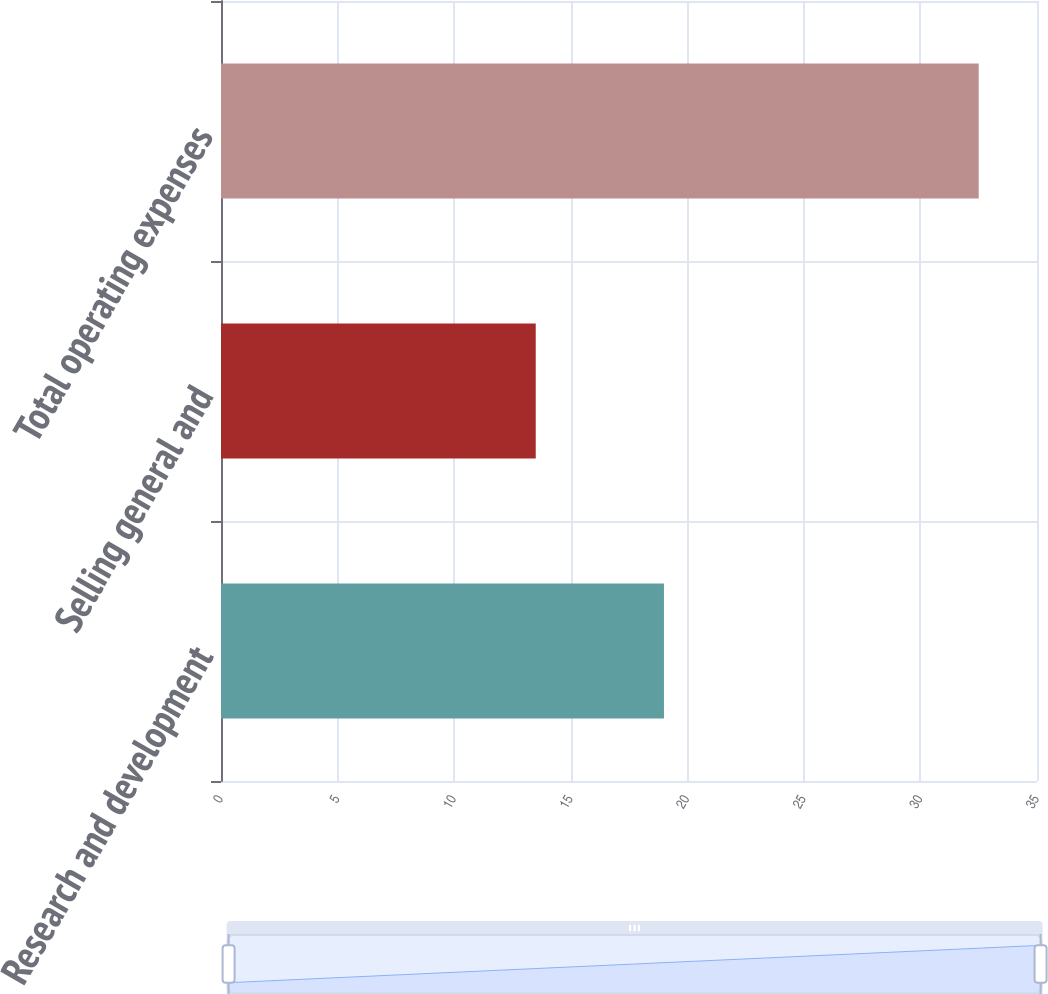Convert chart to OTSL. <chart><loc_0><loc_0><loc_500><loc_500><bar_chart><fcel>Research and development<fcel>Selling general and<fcel>Total operating expenses<nl><fcel>19<fcel>13.5<fcel>32.5<nl></chart> 